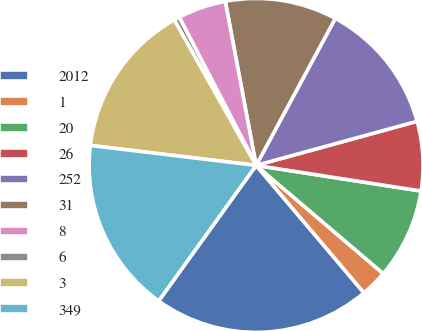<chart> <loc_0><loc_0><loc_500><loc_500><pie_chart><fcel>2012<fcel>1<fcel>20<fcel>26<fcel>252<fcel>31<fcel>8<fcel>6<fcel>3<fcel>349<nl><fcel>21.1%<fcel>2.6%<fcel>8.77%<fcel>6.71%<fcel>12.88%<fcel>10.82%<fcel>4.66%<fcel>0.55%<fcel>14.93%<fcel>16.99%<nl></chart> 